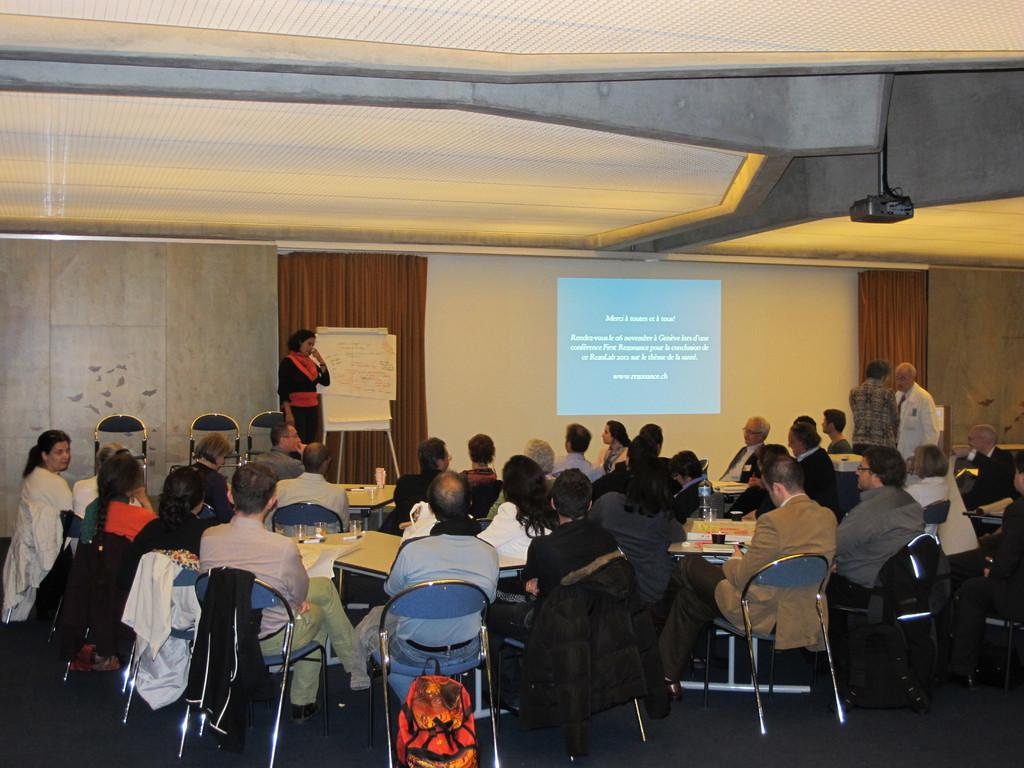What are the people in the image doing? The people in the image are sitting on chairs. What can be seen in the background of the image? There is a screen and a board in the background of the image. Are there any other people visible in the image? Yes, there are three persons standing in the background of the image. What type of question is being asked by the person holding a hammer in the image? There is no person holding a hammer in the image, and therefore no question is being asked. 